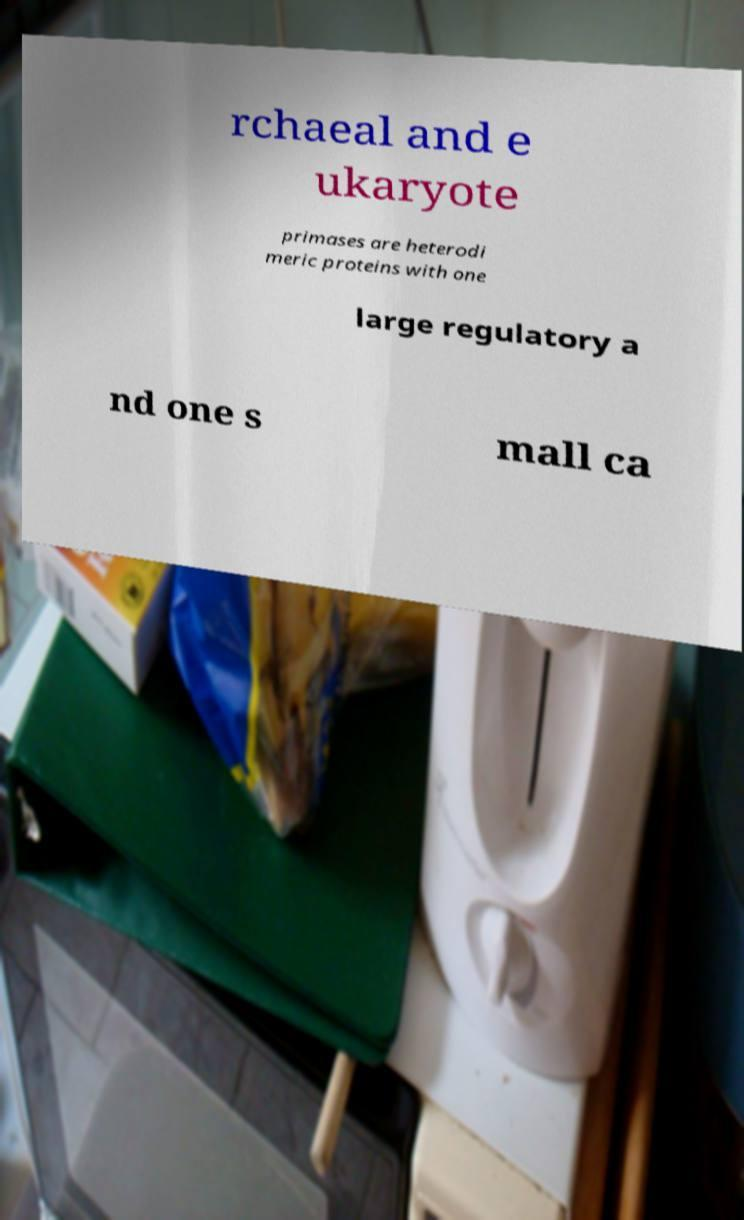Please read and relay the text visible in this image. What does it say? rchaeal and e ukaryote primases are heterodi meric proteins with one large regulatory a nd one s mall ca 